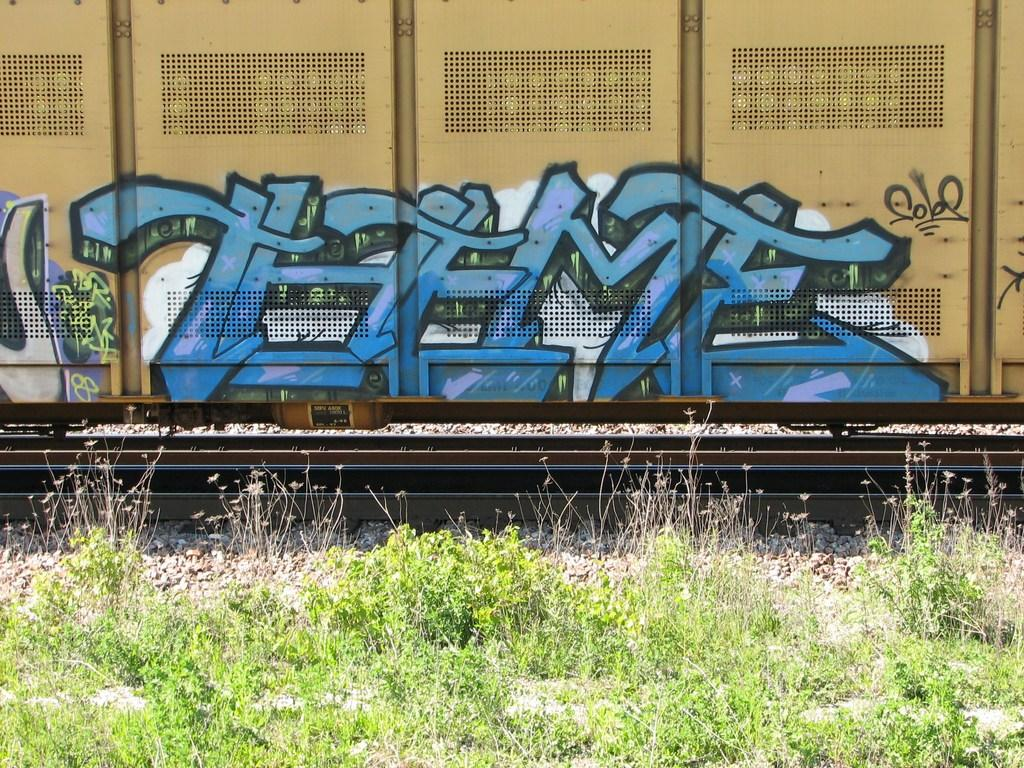<image>
Share a concise interpretation of the image provided. Theme is written out in blue block letters on a train. 